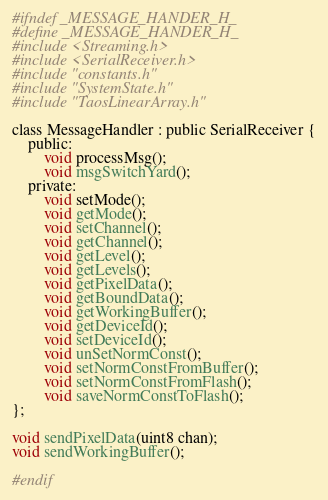<code> <loc_0><loc_0><loc_500><loc_500><_C_>#ifndef _MESSAGE_HANDER_H_
#define _MESSAGE_HANDER_H_
#include <Streaming.h>
#include <SerialReceiver.h>
#include "constants.h"
#include "SystemState.h"
#include "TaosLinearArray.h"

class MessageHandler : public SerialReceiver {
    public:
        void processMsg();
        void msgSwitchYard();
    private:
        void setMode();
        void getMode();
        void setChannel();
        void getChannel();
        void getLevel();
        void getLevels();
        void getPixelData();
        void getBoundData();
        void getWorkingBuffer();
        void getDeviceId();
        void setDeviceId();
        void unSetNormConst();
        void setNormConstFromBuffer();
        void setNormConstFromFlash();
        void saveNormConstToFlash();
};

void sendPixelData(uint8 chan);
void sendWorkingBuffer();

#endif
</code> 